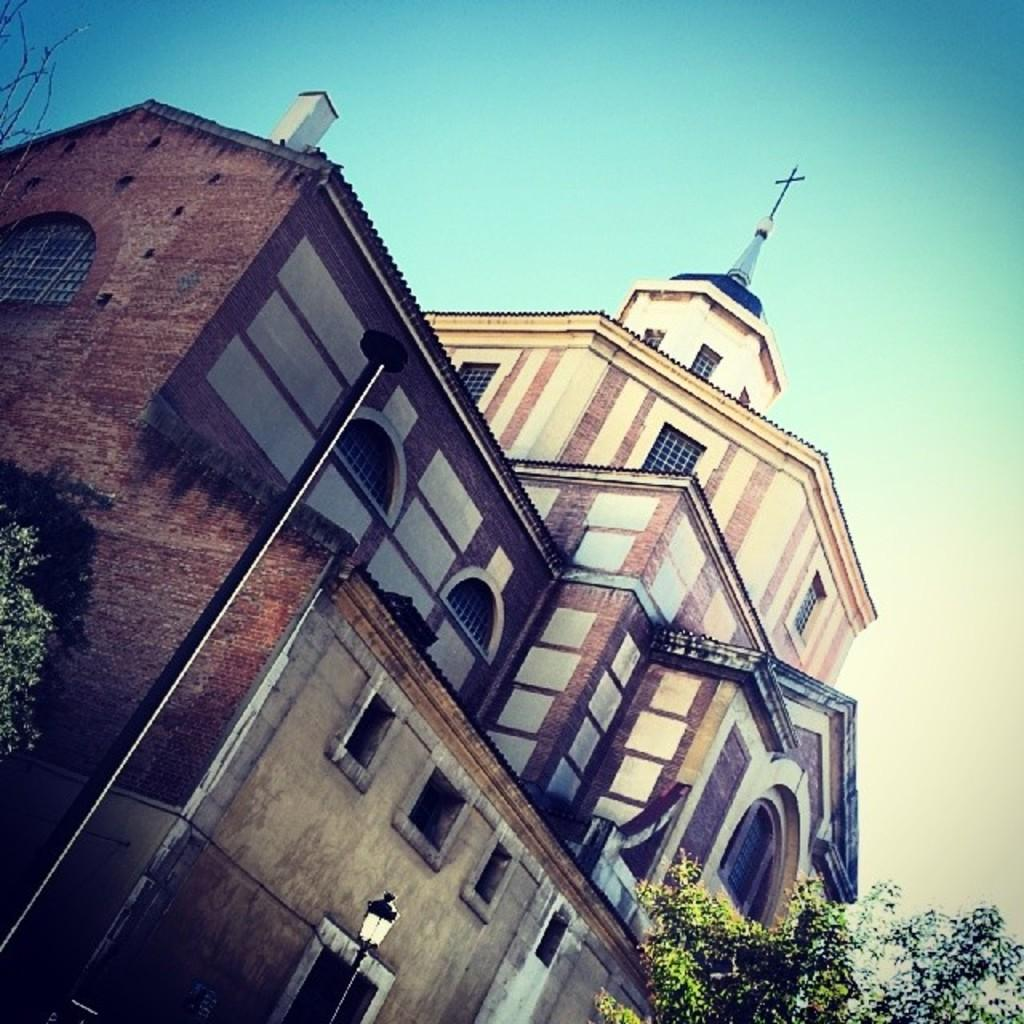What type of structure is present in the image? There is a building in the image. What is located in front of the building? There is a tree and a street light pole in front of the building. What can be seen in the sky in the image? The sky is visible in the image. Are there any giants visible in the image? No, there are no giants present in the image. What type of park can be seen in the image? There is no park visible in the image; it features a building, a tree, and a street light pole. 